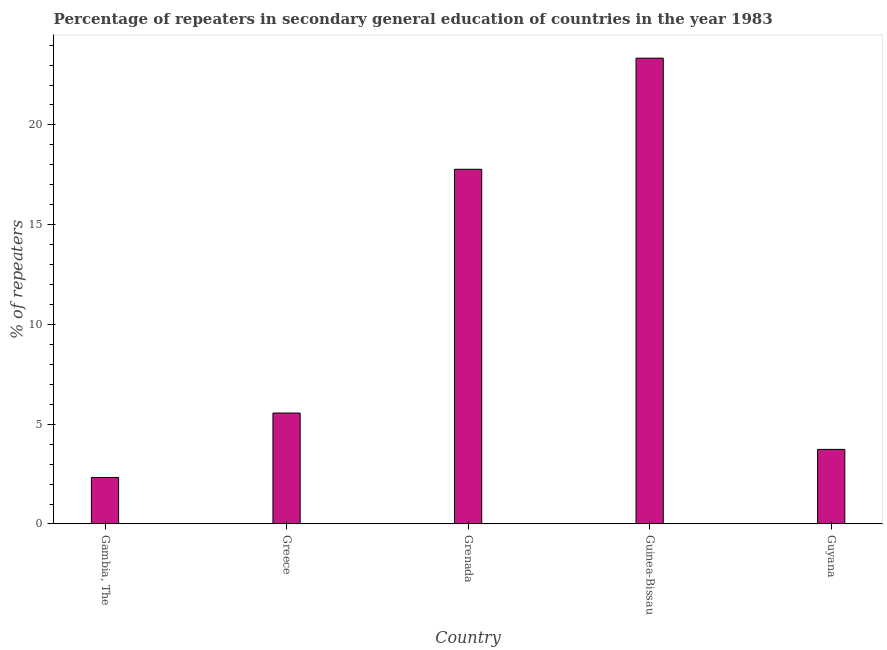Does the graph contain grids?
Your response must be concise. No. What is the title of the graph?
Provide a succinct answer. Percentage of repeaters in secondary general education of countries in the year 1983. What is the label or title of the Y-axis?
Your answer should be compact. % of repeaters. What is the percentage of repeaters in Guinea-Bissau?
Your answer should be compact. 23.35. Across all countries, what is the maximum percentage of repeaters?
Ensure brevity in your answer.  23.35. Across all countries, what is the minimum percentage of repeaters?
Keep it short and to the point. 2.33. In which country was the percentage of repeaters maximum?
Make the answer very short. Guinea-Bissau. In which country was the percentage of repeaters minimum?
Ensure brevity in your answer.  Gambia, The. What is the sum of the percentage of repeaters?
Ensure brevity in your answer.  52.76. What is the difference between the percentage of repeaters in Greece and Guinea-Bissau?
Your answer should be compact. -17.79. What is the average percentage of repeaters per country?
Your answer should be compact. 10.55. What is the median percentage of repeaters?
Your response must be concise. 5.56. What is the ratio of the percentage of repeaters in Grenada to that in Guinea-Bissau?
Give a very brief answer. 0.76. What is the difference between the highest and the second highest percentage of repeaters?
Make the answer very short. 5.57. What is the difference between the highest and the lowest percentage of repeaters?
Ensure brevity in your answer.  21.02. In how many countries, is the percentage of repeaters greater than the average percentage of repeaters taken over all countries?
Ensure brevity in your answer.  2. How many bars are there?
Your answer should be very brief. 5. What is the % of repeaters in Gambia, The?
Give a very brief answer. 2.33. What is the % of repeaters of Greece?
Offer a very short reply. 5.56. What is the % of repeaters of Grenada?
Your response must be concise. 17.78. What is the % of repeaters in Guinea-Bissau?
Provide a succinct answer. 23.35. What is the % of repeaters of Guyana?
Give a very brief answer. 3.74. What is the difference between the % of repeaters in Gambia, The and Greece?
Offer a very short reply. -3.23. What is the difference between the % of repeaters in Gambia, The and Grenada?
Your response must be concise. -15.45. What is the difference between the % of repeaters in Gambia, The and Guinea-Bissau?
Give a very brief answer. -21.02. What is the difference between the % of repeaters in Gambia, The and Guyana?
Offer a very short reply. -1.41. What is the difference between the % of repeaters in Greece and Grenada?
Provide a succinct answer. -12.22. What is the difference between the % of repeaters in Greece and Guinea-Bissau?
Offer a very short reply. -17.79. What is the difference between the % of repeaters in Greece and Guyana?
Provide a succinct answer. 1.82. What is the difference between the % of repeaters in Grenada and Guinea-Bissau?
Make the answer very short. -5.57. What is the difference between the % of repeaters in Grenada and Guyana?
Provide a short and direct response. 14.04. What is the difference between the % of repeaters in Guinea-Bissau and Guyana?
Your response must be concise. 19.61. What is the ratio of the % of repeaters in Gambia, The to that in Greece?
Provide a succinct answer. 0.42. What is the ratio of the % of repeaters in Gambia, The to that in Grenada?
Your answer should be very brief. 0.13. What is the ratio of the % of repeaters in Gambia, The to that in Guinea-Bissau?
Offer a very short reply. 0.1. What is the ratio of the % of repeaters in Gambia, The to that in Guyana?
Offer a terse response. 0.62. What is the ratio of the % of repeaters in Greece to that in Grenada?
Provide a succinct answer. 0.31. What is the ratio of the % of repeaters in Greece to that in Guinea-Bissau?
Your answer should be compact. 0.24. What is the ratio of the % of repeaters in Greece to that in Guyana?
Make the answer very short. 1.49. What is the ratio of the % of repeaters in Grenada to that in Guinea-Bissau?
Keep it short and to the point. 0.76. What is the ratio of the % of repeaters in Grenada to that in Guyana?
Your response must be concise. 4.76. What is the ratio of the % of repeaters in Guinea-Bissau to that in Guyana?
Keep it short and to the point. 6.25. 